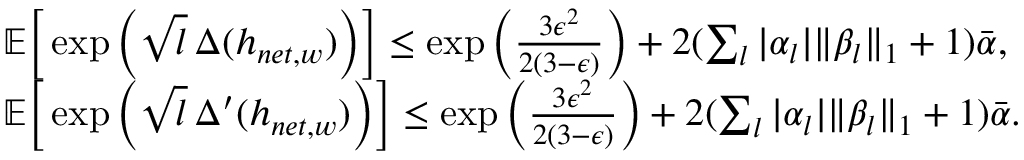Convert formula to latex. <formula><loc_0><loc_0><loc_500><loc_500>\begin{array} { r l } & { \mathbb { E } \left [ \exp \left ( \sqrt { l } \, \Delta ( h _ { n e t , w } ) \right ) \right ] \leq \exp \left ( \frac { 3 \epsilon ^ { 2 } } { 2 ( 3 - \epsilon ) } \right ) + 2 ( \sum _ { l } | \alpha _ { l } | \| \beta _ { l } \| _ { 1 } + 1 ) \bar { \alpha } , } \\ & { \mathbb { E } \left [ \exp \left ( \sqrt { l } \, \Delta ^ { \prime } ( h _ { n e t , w } ) \right ) \right ] \leq \exp \left ( \frac { 3 \epsilon ^ { 2 } } { 2 ( 3 - \epsilon ) } \right ) + 2 ( \sum _ { l } | \alpha _ { l } | \| \beta _ { l } \| _ { 1 } + 1 ) \bar { \alpha } . } \end{array}</formula> 